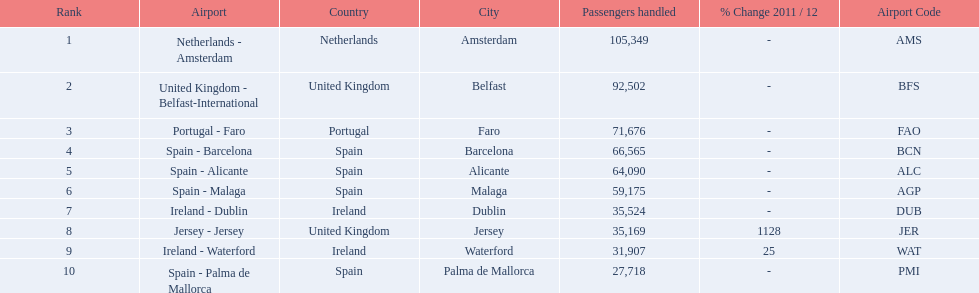Which airports are in europe? Netherlands - Amsterdam, United Kingdom - Belfast-International, Portugal - Faro, Spain - Barcelona, Spain - Alicante, Spain - Malaga, Ireland - Dublin, Ireland - Waterford, Spain - Palma de Mallorca. Which one is from portugal? Portugal - Faro. 